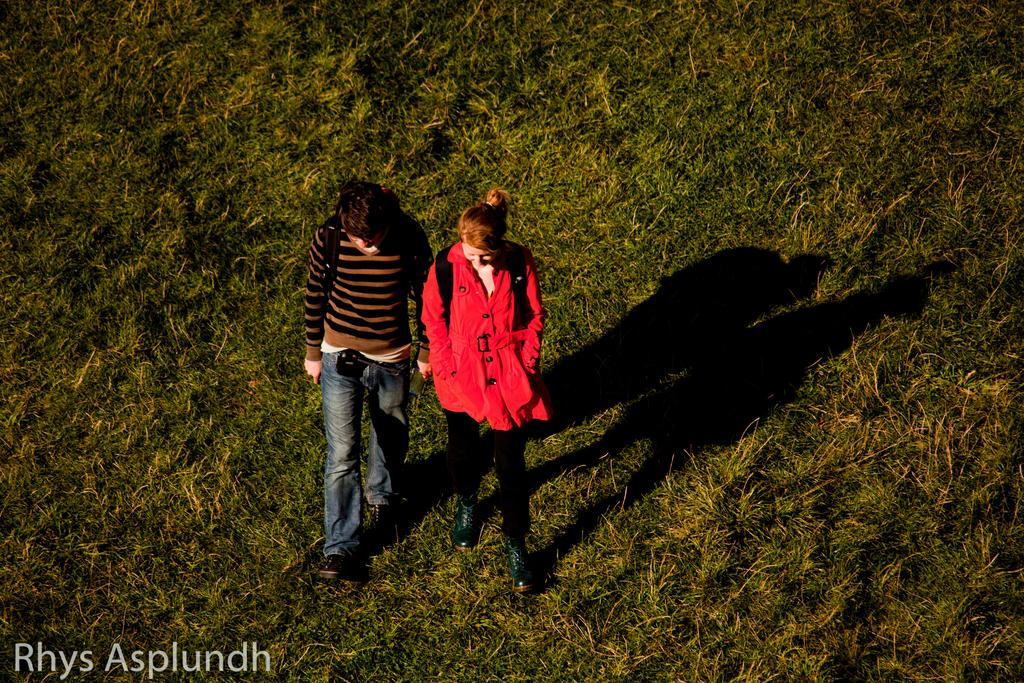How many people are in the image? There are two persons in the image. What is the ground covered with? There is green grass on the ground. What are the persons carrying on their backs? Both persons are wearing backpacks. Can you describe any other feature visible on the ground? There is a shadow visible on the ground. What type of clock is hanging from the tree in the image? There is no clock present in the image, and no tree is mentioned in the facts. 